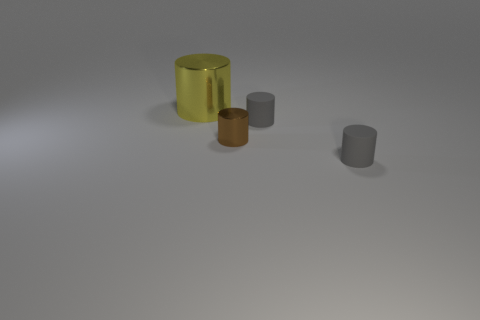What number of gray cylinders have the same material as the yellow thing?
Provide a succinct answer. 0. How many things are either yellow cylinders to the left of the brown shiny cylinder or objects right of the big cylinder?
Offer a very short reply. 4. Is the number of big cylinders that are behind the tiny brown cylinder greater than the number of yellow shiny cylinders on the left side of the big yellow cylinder?
Your response must be concise. Yes. There is a cylinder that is in front of the brown object; what color is it?
Your response must be concise. Gray. Are there any large metallic objects that have the same shape as the small brown thing?
Offer a very short reply. Yes. How many yellow things are either tiny matte objects or large cylinders?
Offer a terse response. 1. Are there any other cylinders that have the same size as the brown metallic cylinder?
Give a very brief answer. Yes. How many big things are there?
Ensure brevity in your answer.  1. How many tiny objects are gray rubber things or yellow matte spheres?
Make the answer very short. 2. There is a shiny cylinder that is in front of the large yellow thing to the left of the shiny cylinder in front of the big metallic object; what color is it?
Your response must be concise. Brown. 